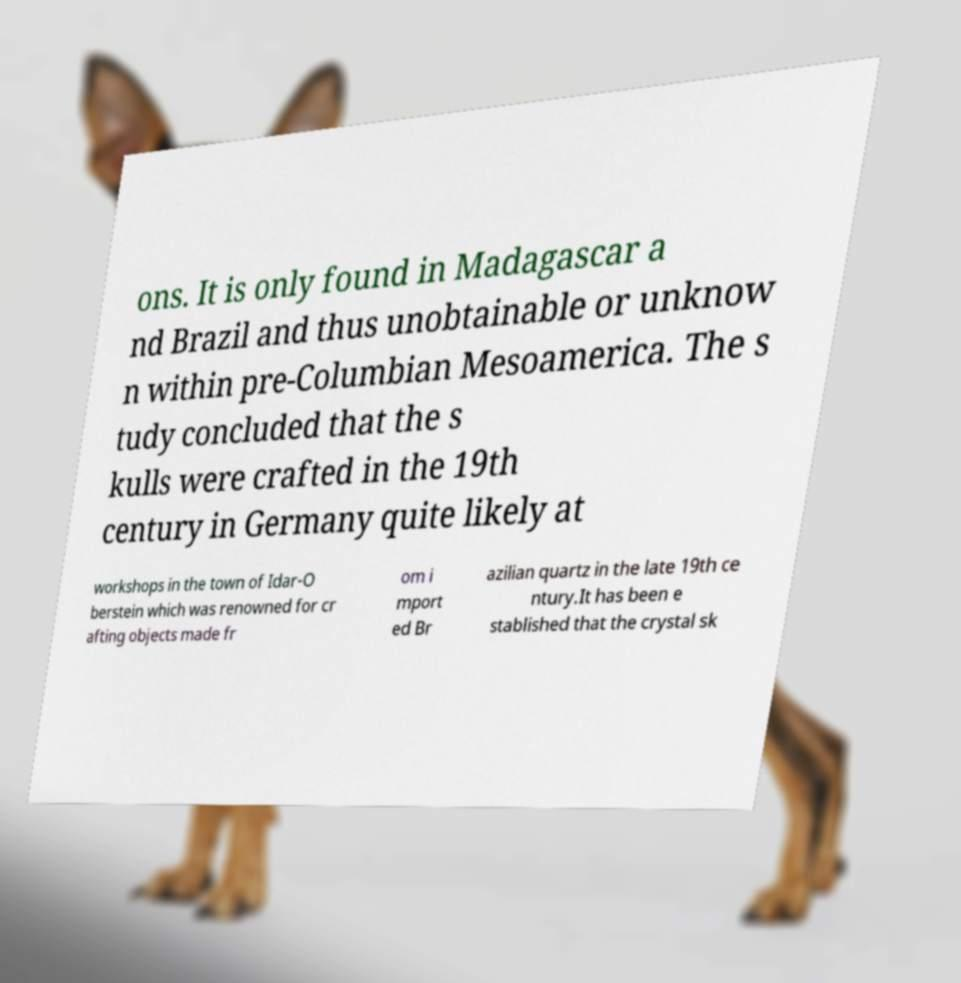There's text embedded in this image that I need extracted. Can you transcribe it verbatim? ons. It is only found in Madagascar a nd Brazil and thus unobtainable or unknow n within pre-Columbian Mesoamerica. The s tudy concluded that the s kulls were crafted in the 19th century in Germany quite likely at workshops in the town of Idar-O berstein which was renowned for cr afting objects made fr om i mport ed Br azilian quartz in the late 19th ce ntury.It has been e stablished that the crystal sk 